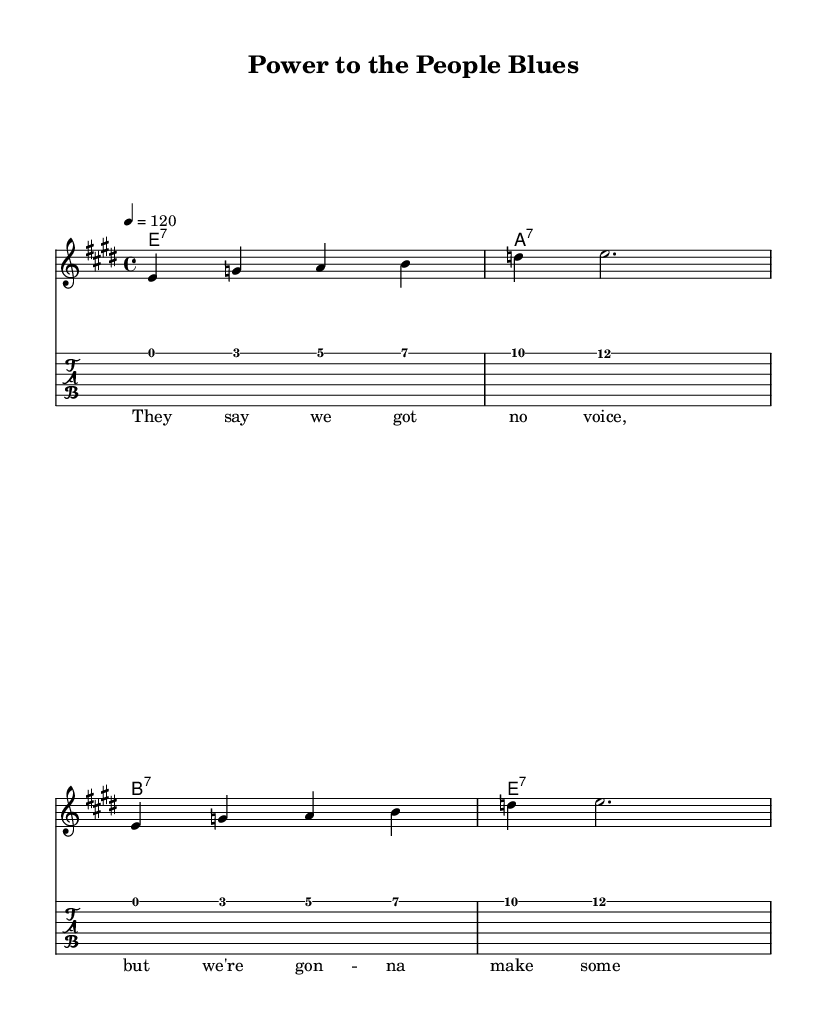What is the key signature of this music? The key signature is E major, which has four sharps (F#, C#, G#, D#). This is indicated by looking at the initial part of the sheet music where the key signature is shown.
Answer: E major What is the time signature of this music? The time signature is 4/4, indicating that there are four beats per measure and the quarter note receives one beat. This can be determined by noting the time signature notation located at the beginning of the sheet music.
Answer: 4/4 What is the tempo of this music? The tempo is 120 beats per minute, as indicated at the beginning of the sheet music with the notation “4 = 120.” This defines how quickly the piece should be played.
Answer: 120 How many measures are in the melody? There are four measures in the melody section, as each line of the melody has four sets of rhythmic values separated by vertical bar lines. By counting these measures within the melody staff, we can confirm this.
Answer: 4 What type of chords are used in this piece? The chords used in this piece are seventh chords, specifically E7, A7, and B7. Each chord is written in a typical electric blues format that emphasizes the seventh structures. This can be determined by examining the chord symbols provided above the melody.
Answer: seventh What is the lyrical theme of the song? The lyrical theme of the song revolves around making noise and asserting a voice in the protest against silence, as indicated by the lyric provided: "They say we got no voice, but we're gon -- na make some noise." This reflects a strong protest-oriented message.
Answer: protest Is the accompaniment for the melody in standard staff notation or tablature? The accompaniment for the melody is shown in both standard staff notation and tablature, which allows guitar players to read and play the music in the format they prefer. This can be seen as there are two distinct staves: one for standard notation and another labeled “TabStaff” for tablature.
Answer: both 